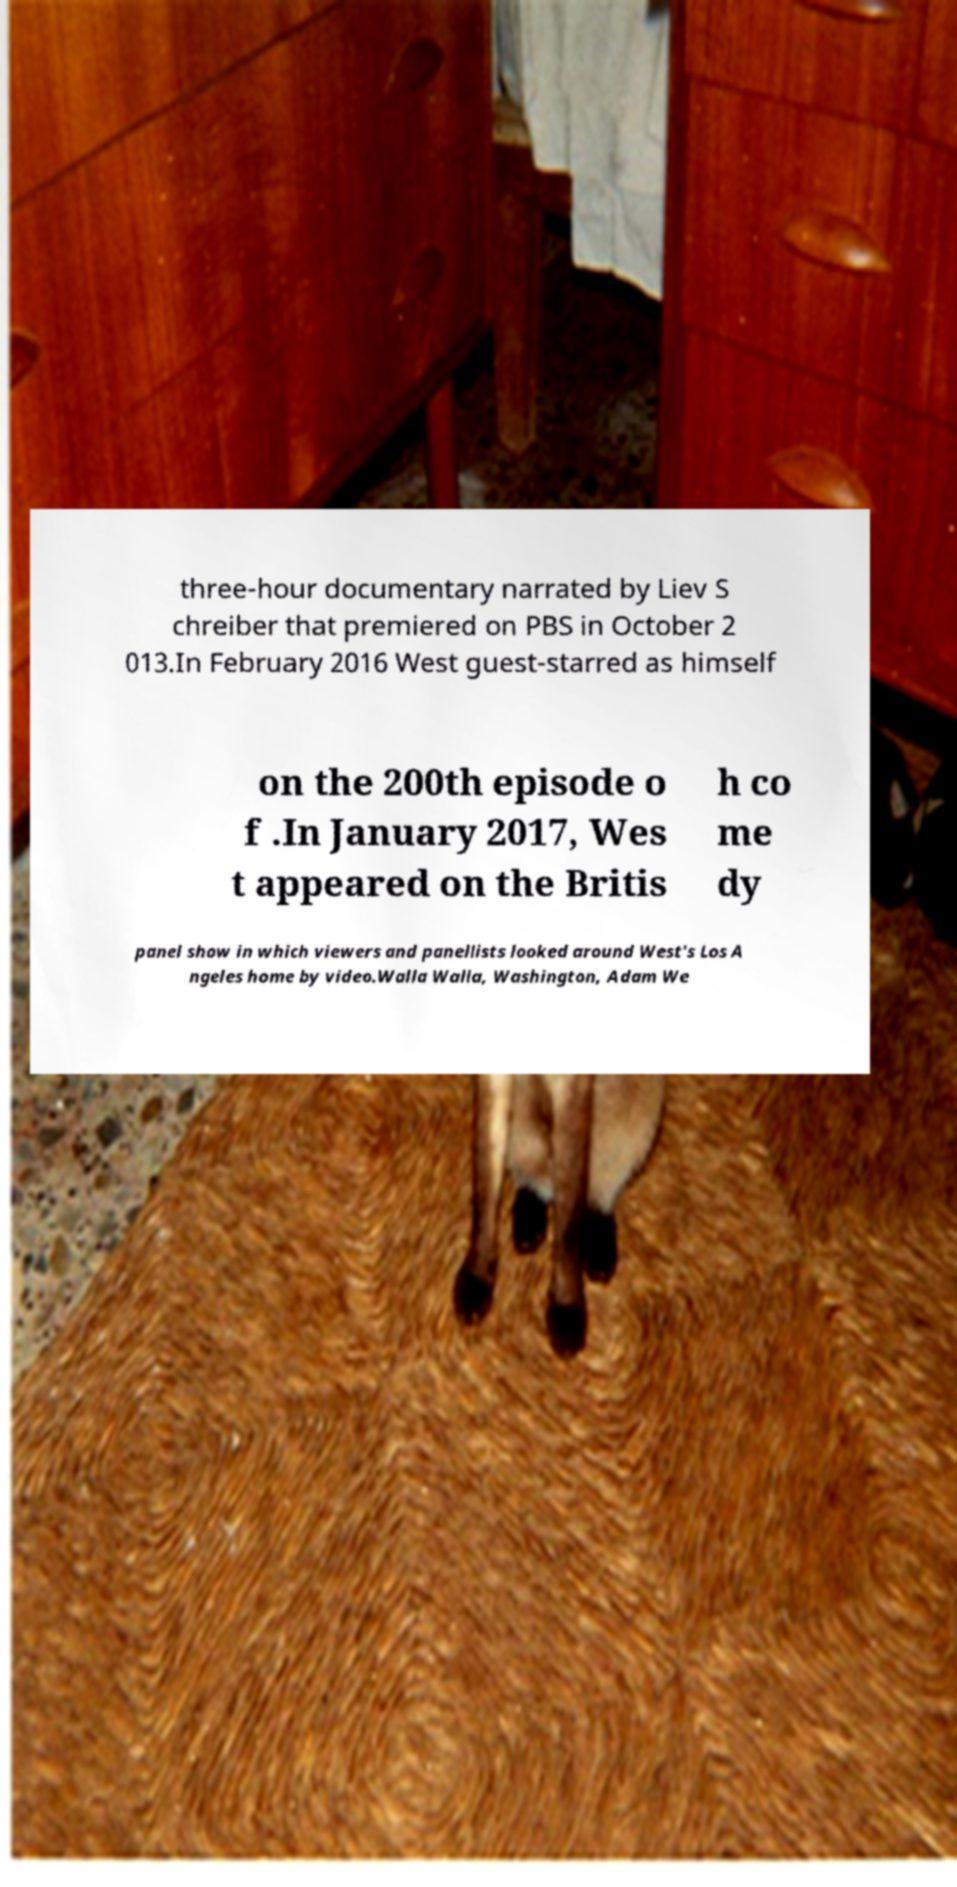Could you assist in decoding the text presented in this image and type it out clearly? three-hour documentary narrated by Liev S chreiber that premiered on PBS in October 2 013.In February 2016 West guest-starred as himself on the 200th episode o f .In January 2017, Wes t appeared on the Britis h co me dy panel show in which viewers and panellists looked around West's Los A ngeles home by video.Walla Walla, Washington, Adam We 